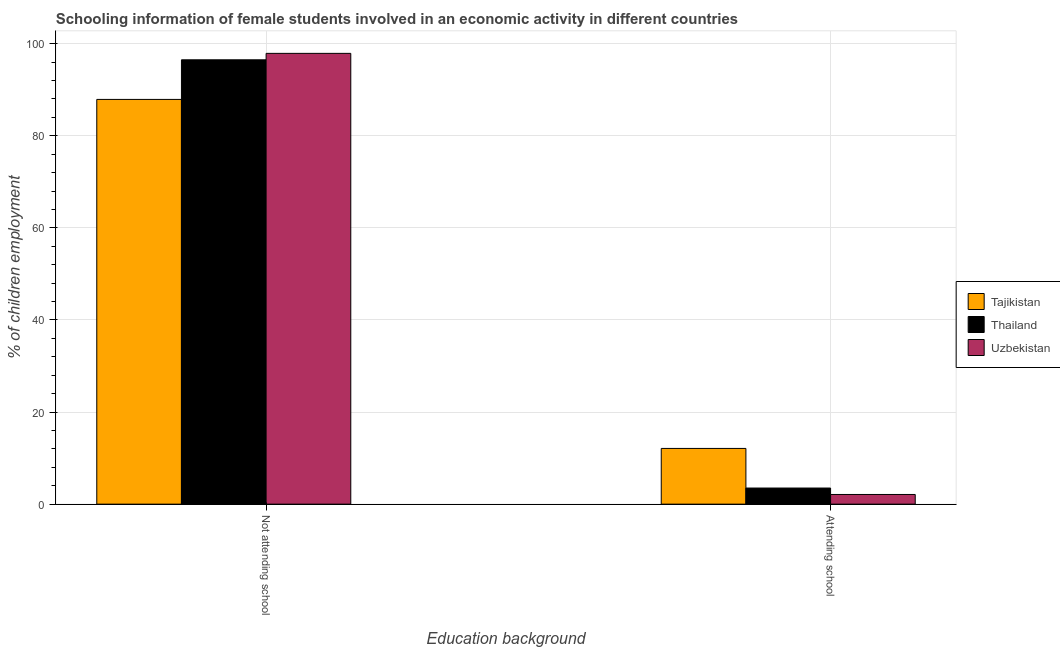How many groups of bars are there?
Provide a short and direct response. 2. Are the number of bars per tick equal to the number of legend labels?
Make the answer very short. Yes. Are the number of bars on each tick of the X-axis equal?
Offer a terse response. Yes. What is the label of the 1st group of bars from the left?
Keep it short and to the point. Not attending school. Across all countries, what is the maximum percentage of employed females who are not attending school?
Your answer should be very brief. 97.9. Across all countries, what is the minimum percentage of employed females who are not attending school?
Ensure brevity in your answer.  87.9. In which country was the percentage of employed females who are not attending school maximum?
Ensure brevity in your answer.  Uzbekistan. In which country was the percentage of employed females who are attending school minimum?
Offer a very short reply. Uzbekistan. What is the total percentage of employed females who are not attending school in the graph?
Your answer should be very brief. 282.3. What is the difference between the percentage of employed females who are not attending school in Thailand and the percentage of employed females who are attending school in Uzbekistan?
Ensure brevity in your answer.  94.4. What is the average percentage of employed females who are not attending school per country?
Keep it short and to the point. 94.1. What is the difference between the percentage of employed females who are not attending school and percentage of employed females who are attending school in Tajikistan?
Keep it short and to the point. 75.8. What is the ratio of the percentage of employed females who are not attending school in Tajikistan to that in Uzbekistan?
Your response must be concise. 0.9. Is the percentage of employed females who are not attending school in Tajikistan less than that in Thailand?
Offer a very short reply. Yes. What does the 1st bar from the left in Not attending school represents?
Provide a succinct answer. Tajikistan. What does the 2nd bar from the right in Not attending school represents?
Offer a very short reply. Thailand. What is the difference between two consecutive major ticks on the Y-axis?
Offer a very short reply. 20. How many legend labels are there?
Give a very brief answer. 3. How are the legend labels stacked?
Make the answer very short. Vertical. What is the title of the graph?
Offer a terse response. Schooling information of female students involved in an economic activity in different countries. Does "Djibouti" appear as one of the legend labels in the graph?
Ensure brevity in your answer.  No. What is the label or title of the X-axis?
Your answer should be compact. Education background. What is the label or title of the Y-axis?
Make the answer very short. % of children employment. What is the % of children employment of Tajikistan in Not attending school?
Keep it short and to the point. 87.9. What is the % of children employment of Thailand in Not attending school?
Offer a very short reply. 96.5. What is the % of children employment of Uzbekistan in Not attending school?
Offer a very short reply. 97.9. Across all Education background, what is the maximum % of children employment in Tajikistan?
Offer a terse response. 87.9. Across all Education background, what is the maximum % of children employment of Thailand?
Give a very brief answer. 96.5. Across all Education background, what is the maximum % of children employment of Uzbekistan?
Ensure brevity in your answer.  97.9. Across all Education background, what is the minimum % of children employment of Tajikistan?
Ensure brevity in your answer.  12.1. Across all Education background, what is the minimum % of children employment in Thailand?
Provide a short and direct response. 3.5. What is the total % of children employment in Tajikistan in the graph?
Ensure brevity in your answer.  100. What is the total % of children employment in Uzbekistan in the graph?
Your response must be concise. 100. What is the difference between the % of children employment of Tajikistan in Not attending school and that in Attending school?
Ensure brevity in your answer.  75.8. What is the difference between the % of children employment of Thailand in Not attending school and that in Attending school?
Your answer should be compact. 93. What is the difference between the % of children employment in Uzbekistan in Not attending school and that in Attending school?
Provide a short and direct response. 95.8. What is the difference between the % of children employment in Tajikistan in Not attending school and the % of children employment in Thailand in Attending school?
Offer a terse response. 84.4. What is the difference between the % of children employment of Tajikistan in Not attending school and the % of children employment of Uzbekistan in Attending school?
Ensure brevity in your answer.  85.8. What is the difference between the % of children employment in Thailand in Not attending school and the % of children employment in Uzbekistan in Attending school?
Your response must be concise. 94.4. What is the average % of children employment in Tajikistan per Education background?
Make the answer very short. 50. What is the difference between the % of children employment in Tajikistan and % of children employment in Thailand in Not attending school?
Your answer should be very brief. -8.6. What is the difference between the % of children employment of Tajikistan and % of children employment of Uzbekistan in Not attending school?
Provide a short and direct response. -10. What is the difference between the % of children employment in Thailand and % of children employment in Uzbekistan in Attending school?
Offer a very short reply. 1.4. What is the ratio of the % of children employment in Tajikistan in Not attending school to that in Attending school?
Offer a very short reply. 7.26. What is the ratio of the % of children employment in Thailand in Not attending school to that in Attending school?
Ensure brevity in your answer.  27.57. What is the ratio of the % of children employment of Uzbekistan in Not attending school to that in Attending school?
Offer a very short reply. 46.62. What is the difference between the highest and the second highest % of children employment in Tajikistan?
Your answer should be very brief. 75.8. What is the difference between the highest and the second highest % of children employment in Thailand?
Offer a very short reply. 93. What is the difference between the highest and the second highest % of children employment of Uzbekistan?
Offer a very short reply. 95.8. What is the difference between the highest and the lowest % of children employment of Tajikistan?
Make the answer very short. 75.8. What is the difference between the highest and the lowest % of children employment in Thailand?
Give a very brief answer. 93. What is the difference between the highest and the lowest % of children employment in Uzbekistan?
Provide a short and direct response. 95.8. 